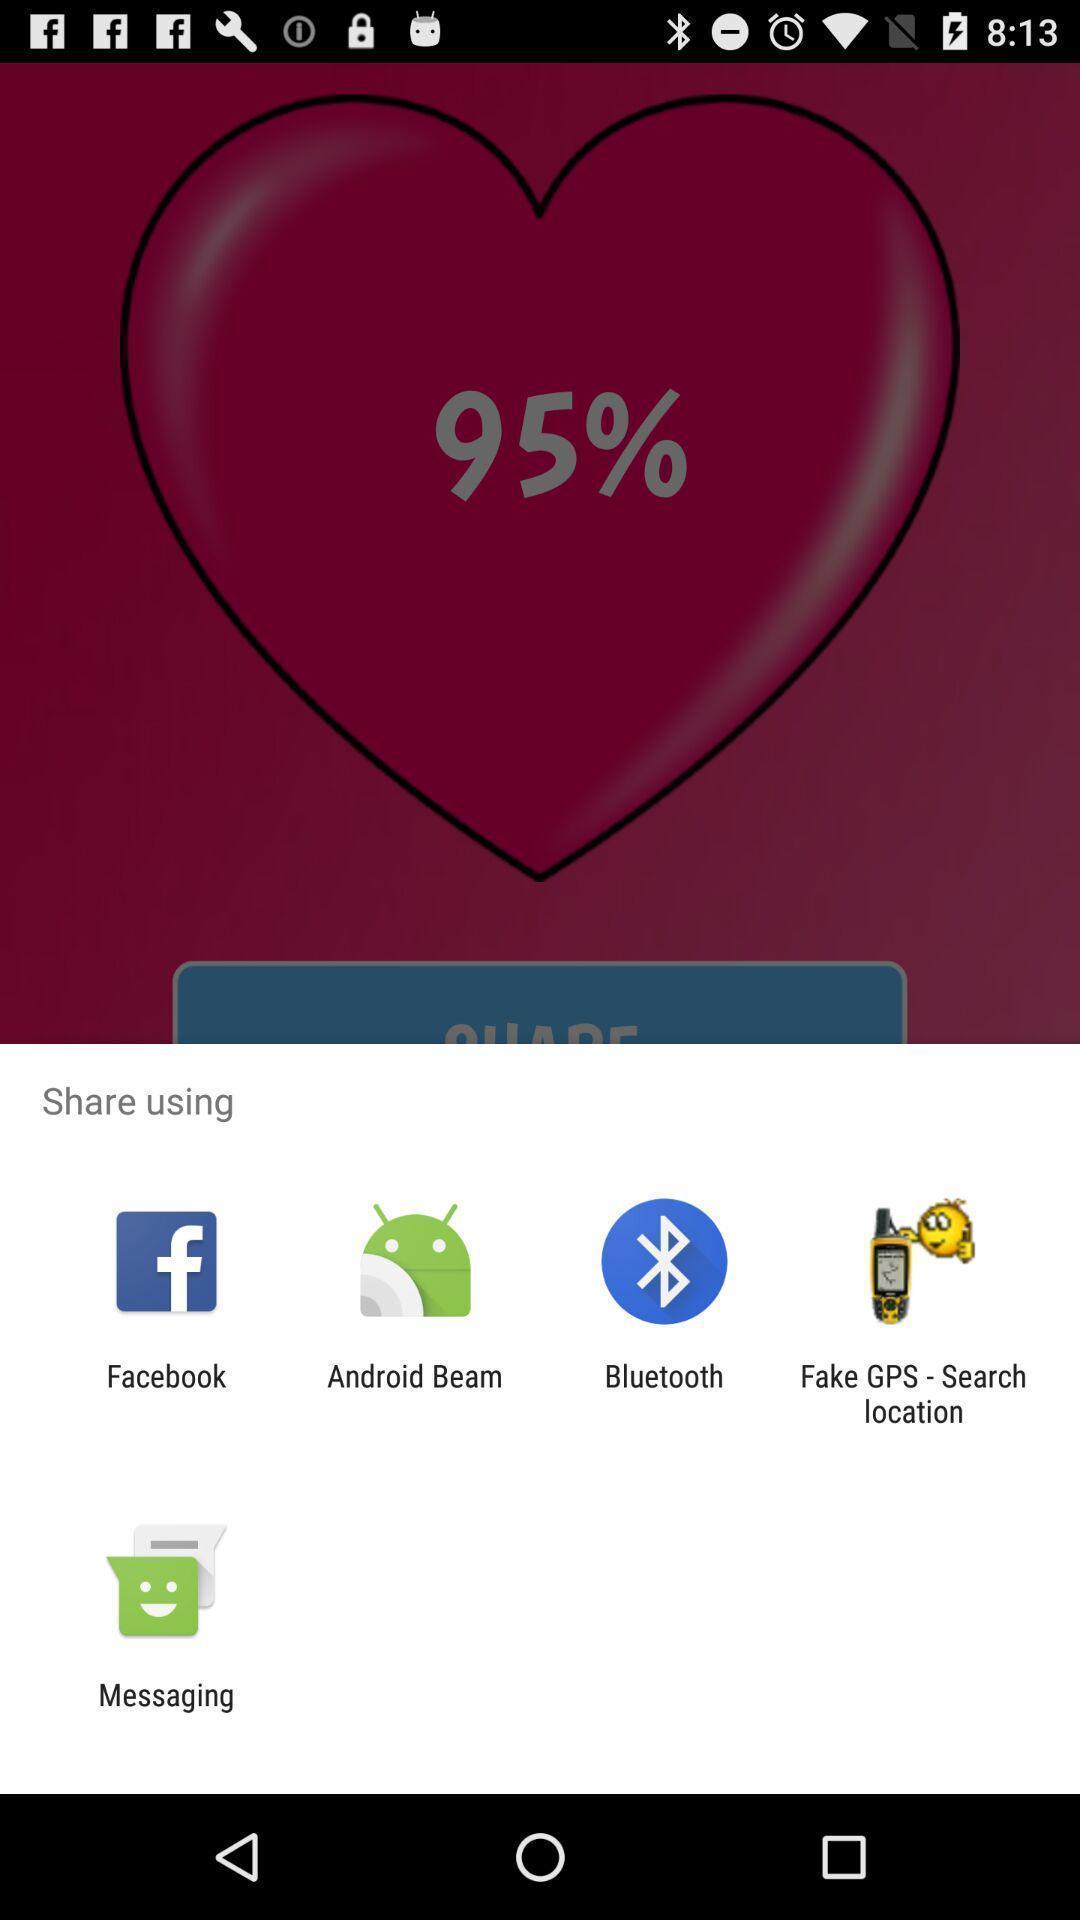Provide a description of this screenshot. Share using pop up with list of sharing app. 